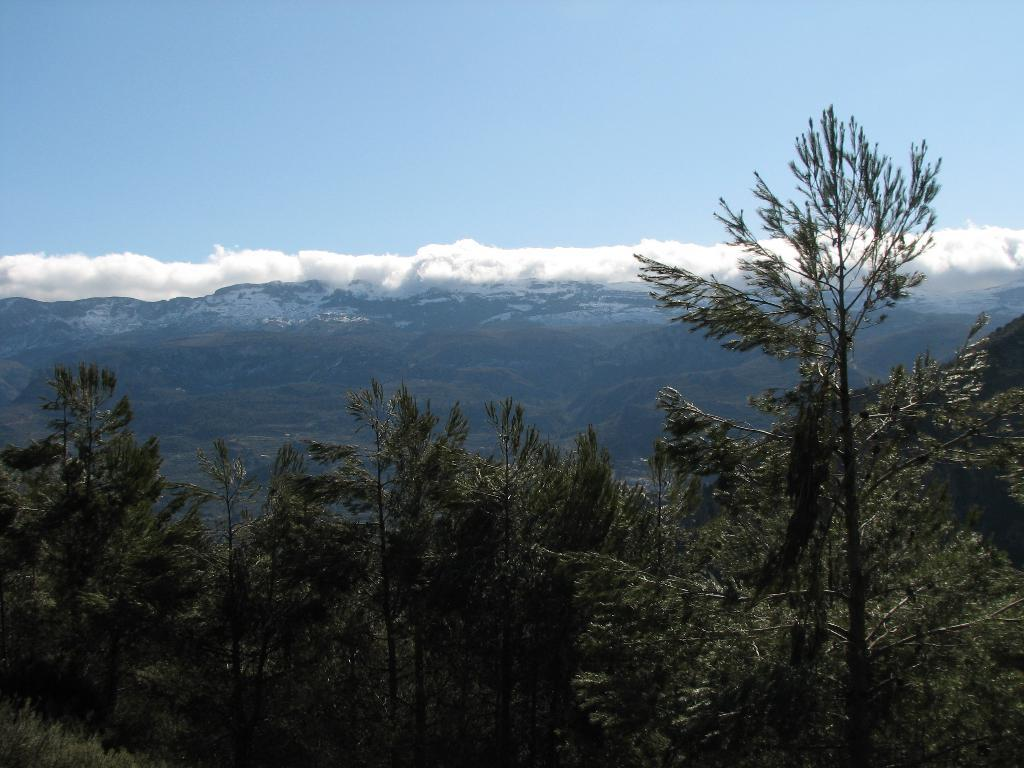What type of vegetation can be seen in the image? There are trees in the image. What can be seen in the distance in the image? There are mountains and clouds in the background of the image. How many beetles can be seen crawling on the trees in the image? There are no beetles visible in the image; it only features trees, mountains, and clouds. 